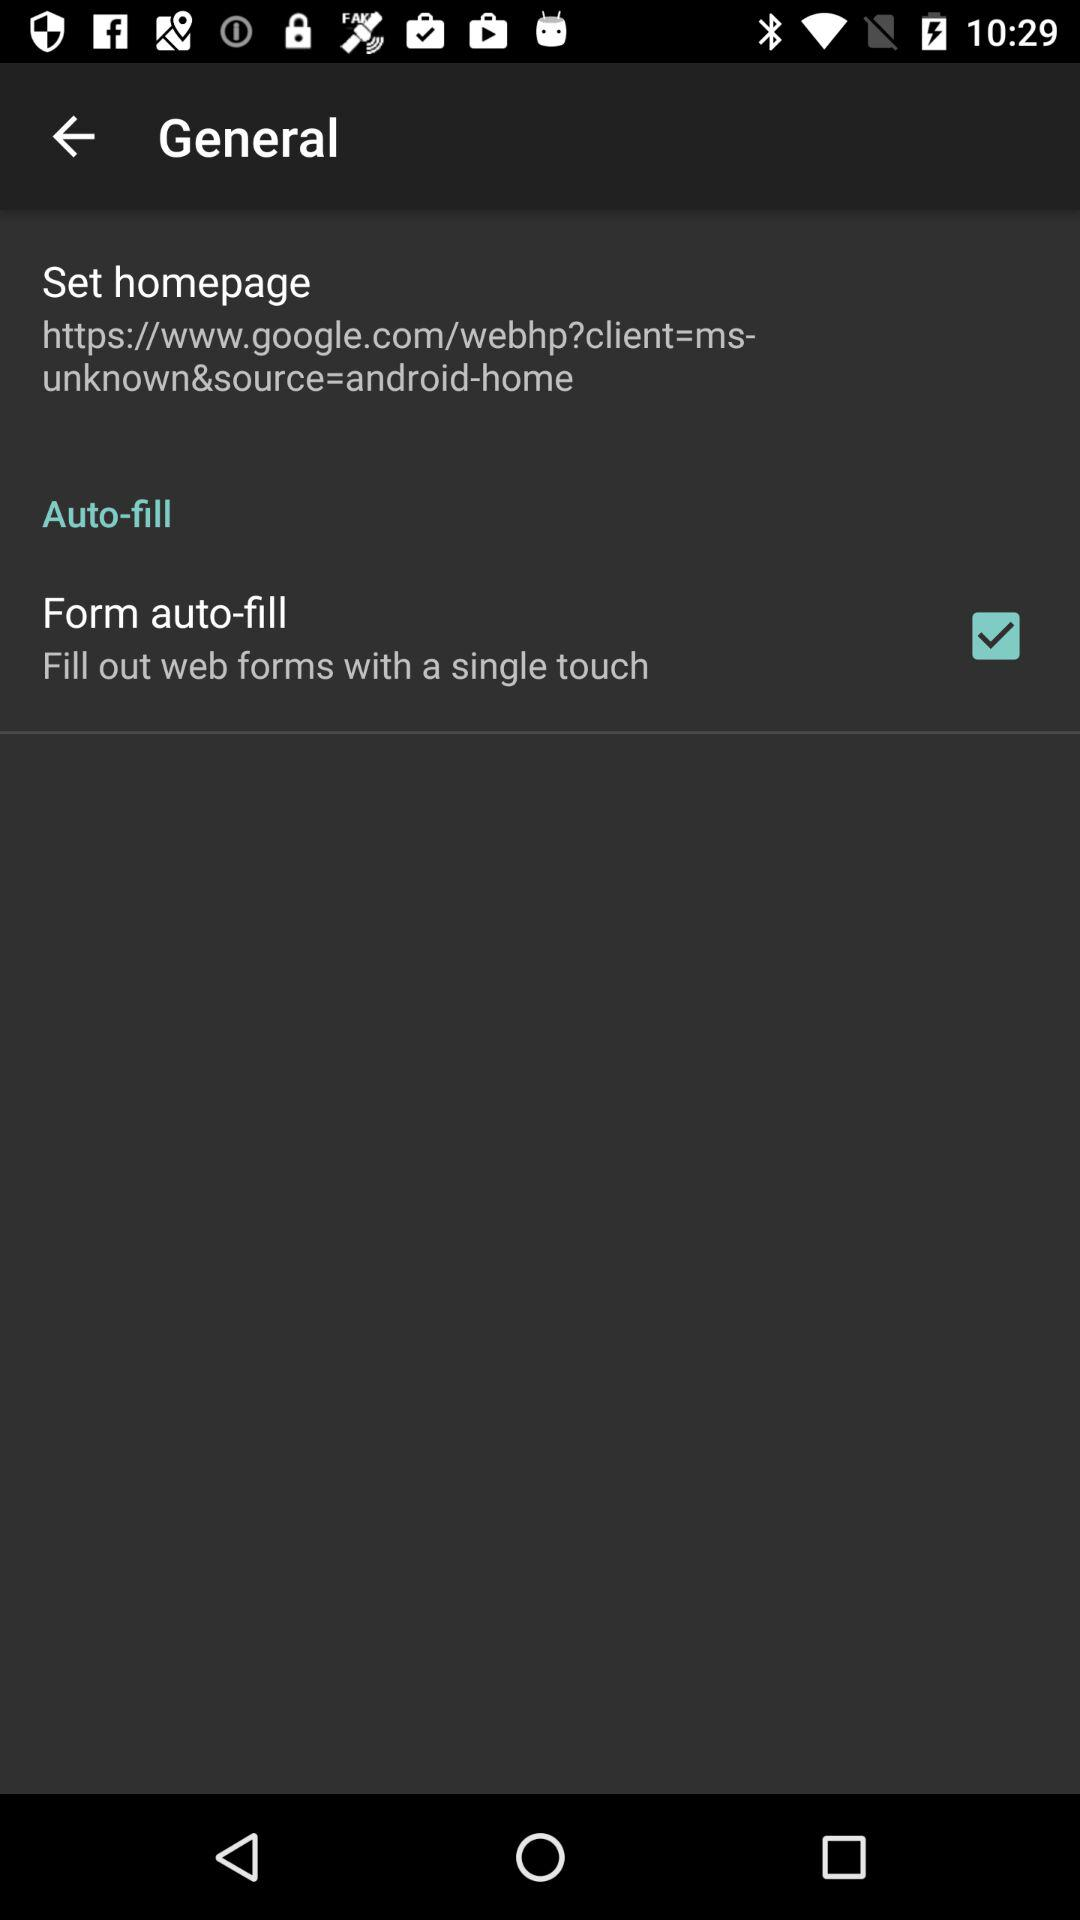How many check boxes are there in the General section?
Answer the question using a single word or phrase. 1 